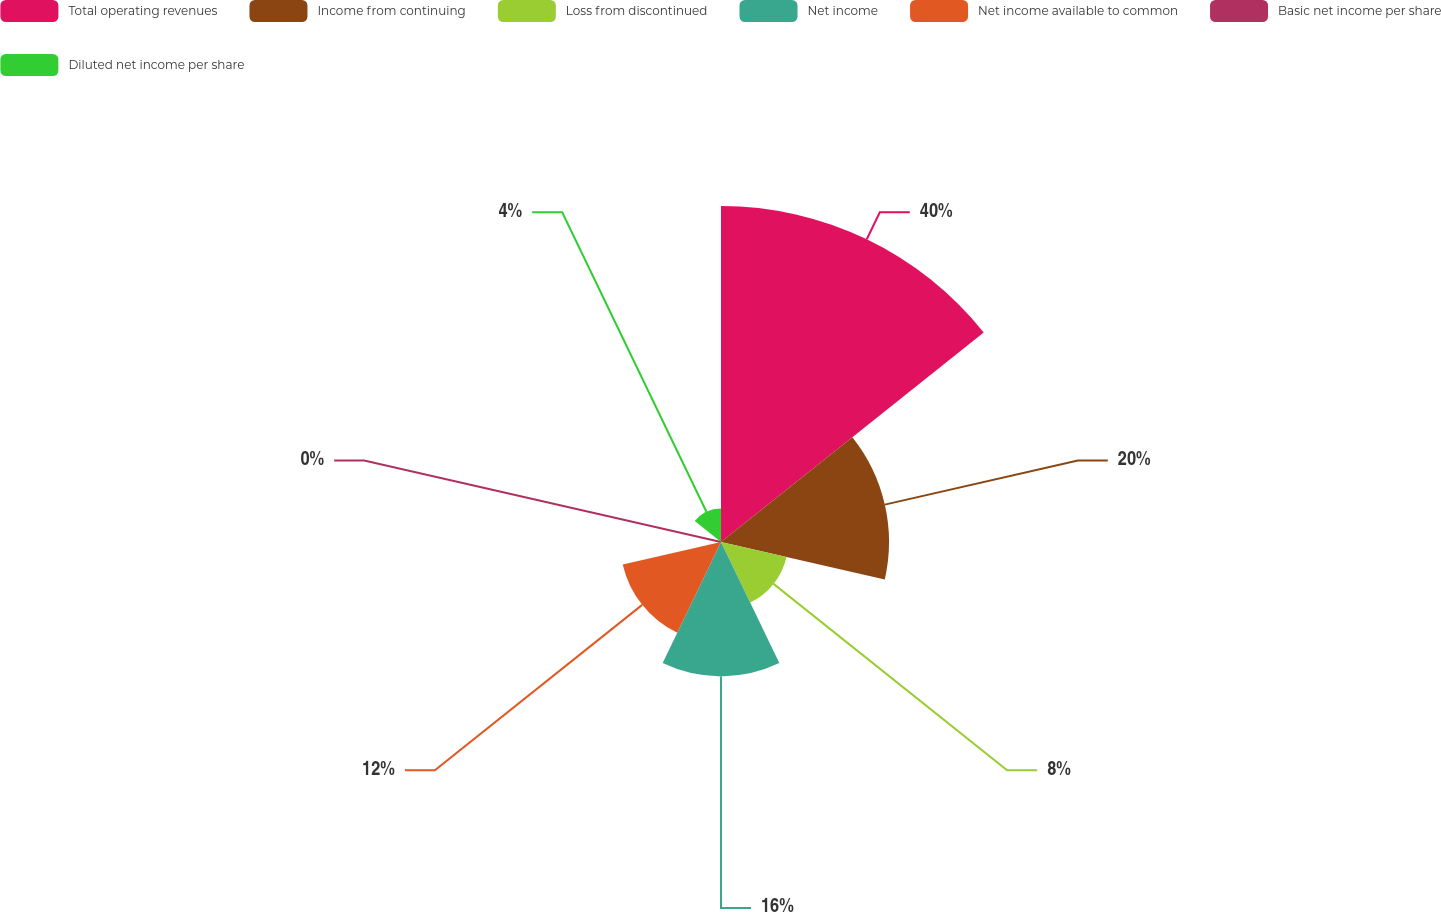<chart> <loc_0><loc_0><loc_500><loc_500><pie_chart><fcel>Total operating revenues<fcel>Income from continuing<fcel>Loss from discontinued<fcel>Net income<fcel>Net income available to common<fcel>Basic net income per share<fcel>Diluted net income per share<nl><fcel>40.0%<fcel>20.0%<fcel>8.0%<fcel>16.0%<fcel>12.0%<fcel>0.0%<fcel>4.0%<nl></chart> 